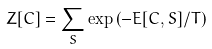Convert formula to latex. <formula><loc_0><loc_0><loc_500><loc_500>Z [ { C } ] = \sum _ { S } \exp \left ( - E [ { C } , { S } ] / T \right )</formula> 